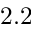Convert formula to latex. <formula><loc_0><loc_0><loc_500><loc_500>2 . 2</formula> 